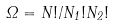<formula> <loc_0><loc_0><loc_500><loc_500>\Omega = N ! / N _ { 1 } ! N _ { 2 } !</formula> 